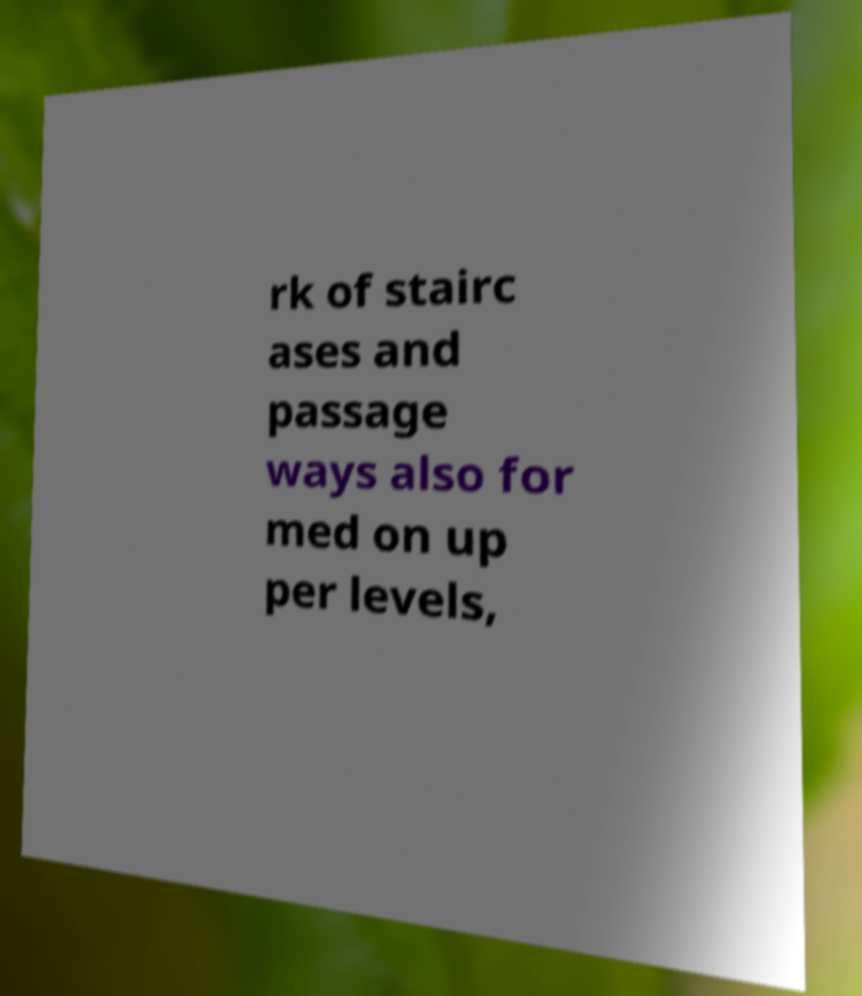What messages or text are displayed in this image? I need them in a readable, typed format. rk of stairc ases and passage ways also for med on up per levels, 